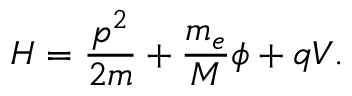Convert formula to latex. <formula><loc_0><loc_0><loc_500><loc_500>H = \frac { p ^ { 2 } } { 2 m } + \frac { m _ { e } } { M } \phi + q V .</formula> 